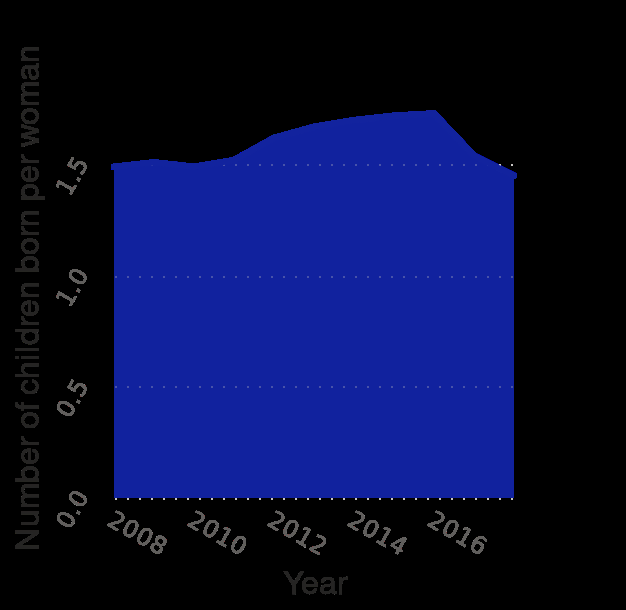<image>
What country is represented by the graph? The graph represents Belarus. Was there any significant change in the number of children born per woman over the 5 years?  Based on the given information, there was no significant change in the number of children born per woman over the 5 years as it did not drop below 1.5. 